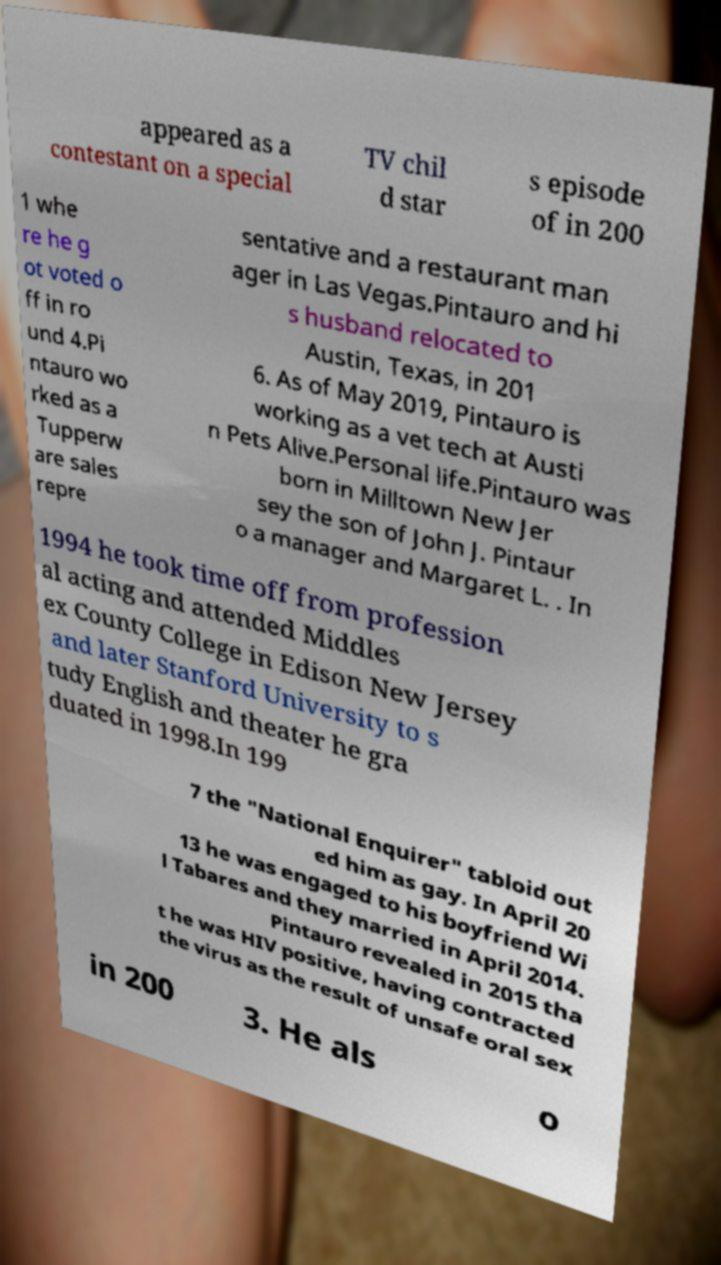There's text embedded in this image that I need extracted. Can you transcribe it verbatim? appeared as a contestant on a special TV chil d star s episode of in 200 1 whe re he g ot voted o ff in ro und 4.Pi ntauro wo rked as a Tupperw are sales repre sentative and a restaurant man ager in Las Vegas.Pintauro and hi s husband relocated to Austin, Texas, in 201 6. As of May 2019, Pintauro is working as a vet tech at Austi n Pets Alive.Personal life.Pintauro was born in Milltown New Jer sey the son of John J. Pintaur o a manager and Margaret L. . In 1994 he took time off from profession al acting and attended Middles ex County College in Edison New Jersey and later Stanford University to s tudy English and theater he gra duated in 1998.In 199 7 the "National Enquirer" tabloid out ed him as gay. In April 20 13 he was engaged to his boyfriend Wi l Tabares and they married in April 2014. Pintauro revealed in 2015 tha t he was HIV positive, having contracted the virus as the result of unsafe oral sex in 200 3. He als o 